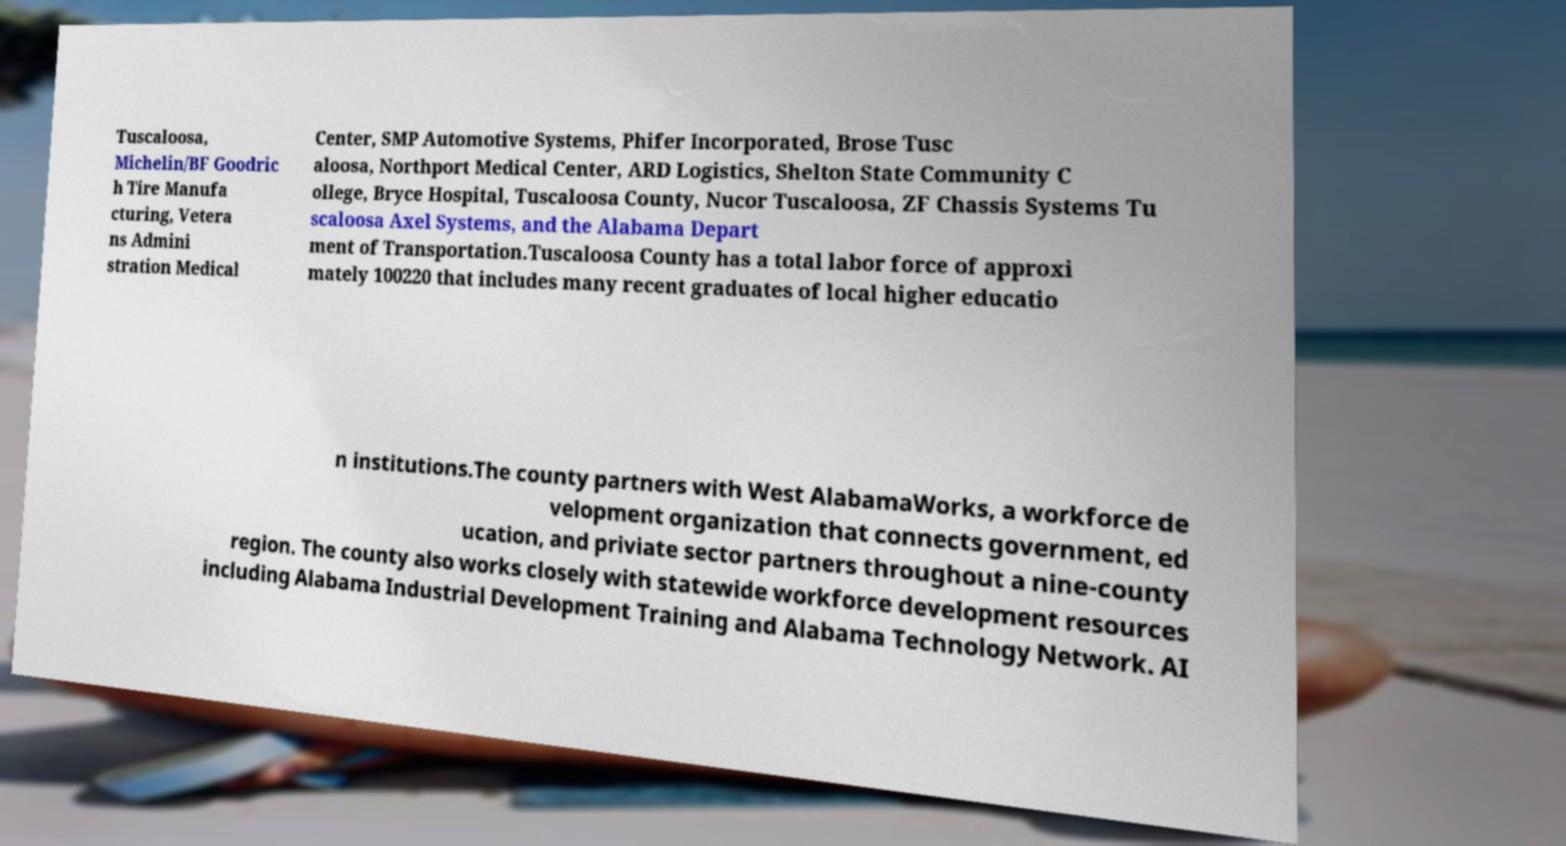What messages or text are displayed in this image? I need them in a readable, typed format. Tuscaloosa, Michelin/BF Goodric h Tire Manufa cturing, Vetera ns Admini stration Medical Center, SMP Automotive Systems, Phifer Incorporated, Brose Tusc aloosa, Northport Medical Center, ARD Logistics, Shelton State Community C ollege, Bryce Hospital, Tuscaloosa County, Nucor Tuscaloosa, ZF Chassis Systems Tu scaloosa Axel Systems, and the Alabama Depart ment of Transportation.Tuscaloosa County has a total labor force of approxi mately 100220 that includes many recent graduates of local higher educatio n institutions.The county partners with West AlabamaWorks, a workforce de velopment organization that connects government, ed ucation, and priviate sector partners throughout a nine-county region. The county also works closely with statewide workforce development resources including Alabama Industrial Development Training and Alabama Technology Network. AI 